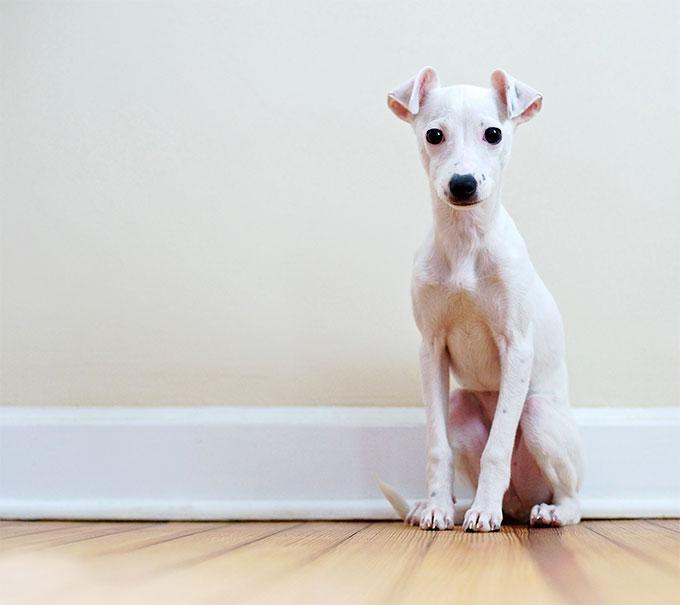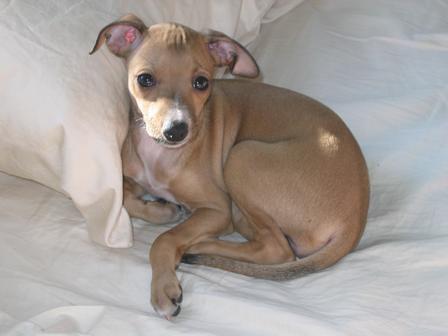The first image is the image on the left, the second image is the image on the right. Analyze the images presented: Is the assertion "A dog is curled up next to some type of cushion." valid? Answer yes or no. Yes. The first image is the image on the left, the second image is the image on the right. Given the left and right images, does the statement "There is at least one dog laying down." hold true? Answer yes or no. Yes. 